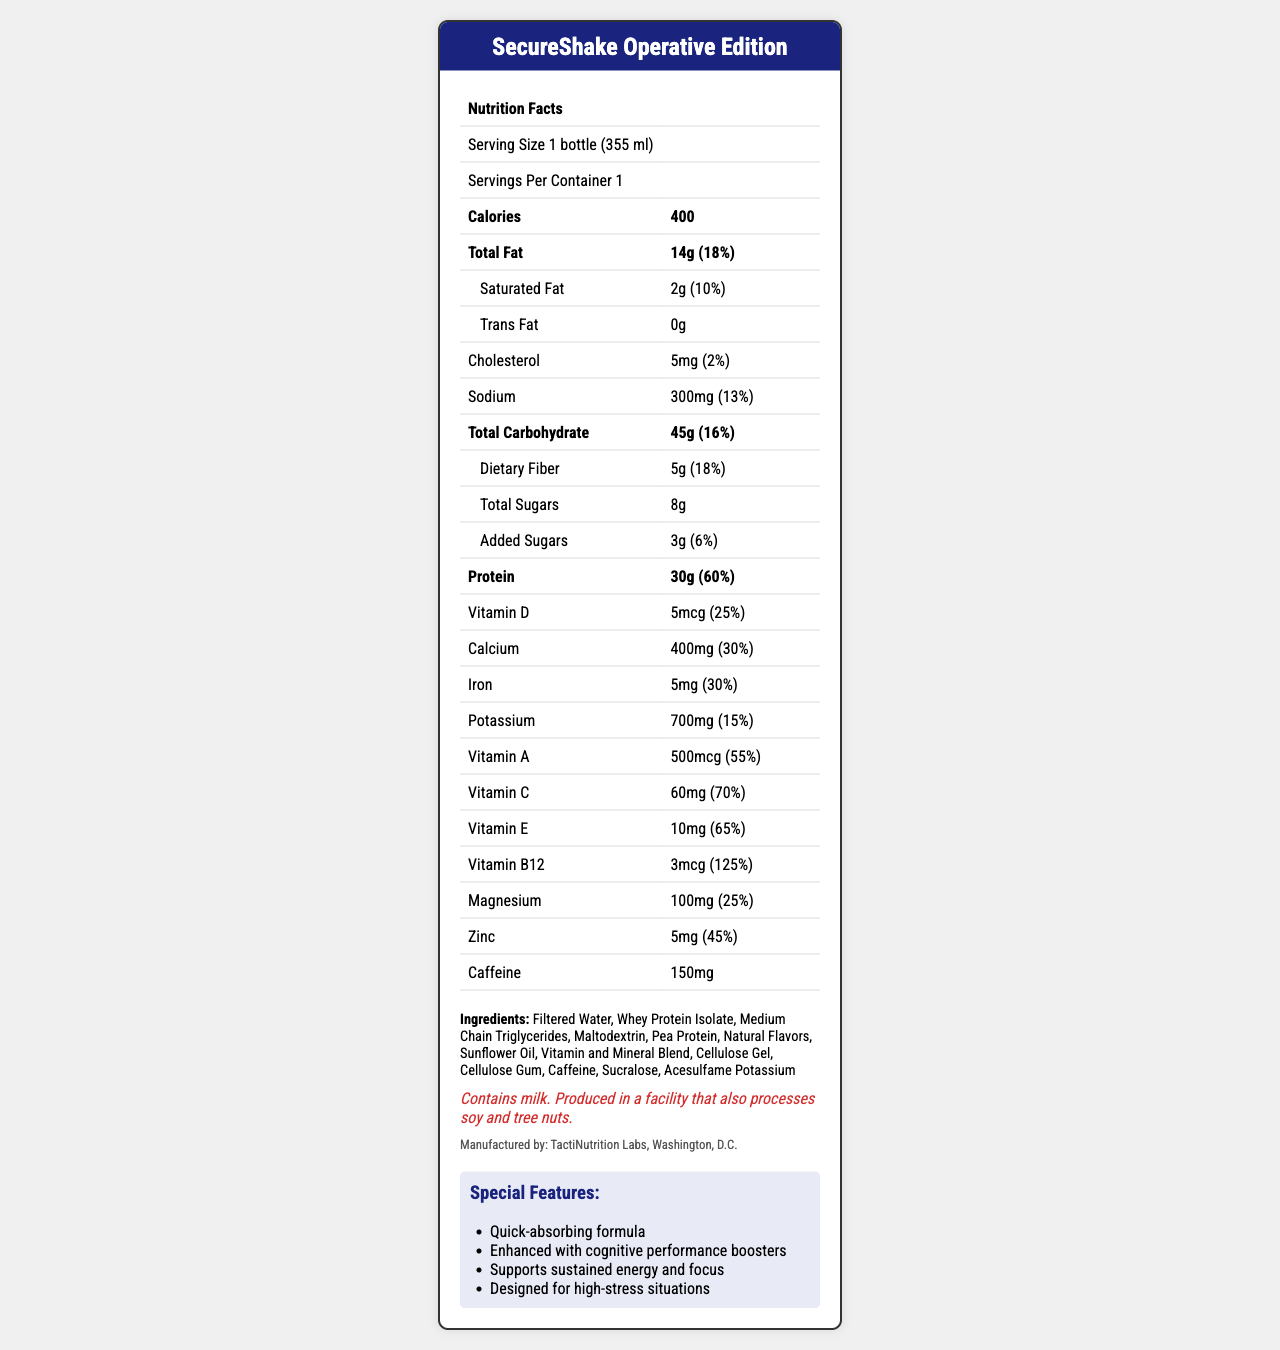what is the serving size? The serving size is clearly mentioned in the document as "1 bottle (355 ml)".
Answer: 1 bottle (355 ml) how many calories are in a serving of SecureShake Operative Edition? The document lists the calorie count for one serving as 400 calories.
Answer: 400 calories what is the amount of total fat per serving, and what percentage of the daily value does this represent? The document specifies "Total Fat" as 14 grams, which is 18% of the daily value.
Answer: 14 grams, 18% what is the main source of protein in the ingredients list? The ingredients list includes Whey Protein Isolate and Pea Protein, which are known sources of protein.
Answer: Whey Protein Isolate and Pea Protein what is the level of caffeine in SecureShake Operative Edition? The document lists the caffeine content as 150 mg.
Answer: 150 mg how much total carbohydrate is contained in one serving? The document indicates the "Total Carbohydrate" as 45 grams, with a daily value percentage of 16%.
Answer: 45 grams (16% of daily value) how much dietary fiber is included in one bottle of SecureShake Operative Edition? The dietary fiber content is specified as 5 grams, which is 18% of the daily value.
Answer: 5 grams (18% of daily value) what are the special features of SecureShake Operative Edition? The document lists these features under "Special Features".
Answer: Quick-absorbing formula, Enhanced with cognitive performance boosters, Supports sustained energy and focus, Designed for high-stress situations which of the following vitamins has the highest percentage of daily value? A. Vitamin D B. Vitamin A C. Vitamin C D. Vitamin B12 Vitamin B12 has a daily value percentage of 125%, which is the highest among the vitamins listed.
Answer: D. Vitamin B12 how many total sugars and added sugars are in SecureShake Operative Edition? A. 8g total sugars, 3g added sugars B. 5g total sugars, 3g added sugars C. 8g total sugars, 0g added sugars D. 5g total sugars, 0g added sugars The document lists "Total Sugars" as 8 grams and "Added Sugars" as 3 grams.
Answer: A. 8g total sugars, 3g added sugars does SecureShake Operative Edition contain any trans fat? The document explicitly states "Trans Fat" as 0 grams.
Answer: No summarize the main characteristics of SecureShake Operative Edition. The summary captures the main nutritional components and special features of the meal replacement shake as described in the document.
Answer: SecureShake Operative Edition is a meal replacement shake designed for quick consumption during intense security operations. It contains 400 calories per serving with 14 grams of total fat and 30 grams of protein. It is rich in several vitamins and minerals, and contains 150 mg of caffeine. The shake is specially formulated for quick absorption and enhanced cognitive performance. what is the manufacturer of SecureShake Operative Edition? The document states that the product is manufactured by TactiNutrition Labs in Washington, D.C.
Answer: TactiNutrition Labs, Washington, D.C. is the information sufficient to determine the shake's flavor? The document does not provide any information regarding the flavor of SecureShake Operative Edition.
Answer: Cannot be determined is SecureShake Operative Edition suitable for someone with a peanut allergy? The document states it is produced in a facility that processes soy and tree nuts but does not specifically mention peanuts. Hence, more information is needed to make this determination.
Answer: Not enough information 